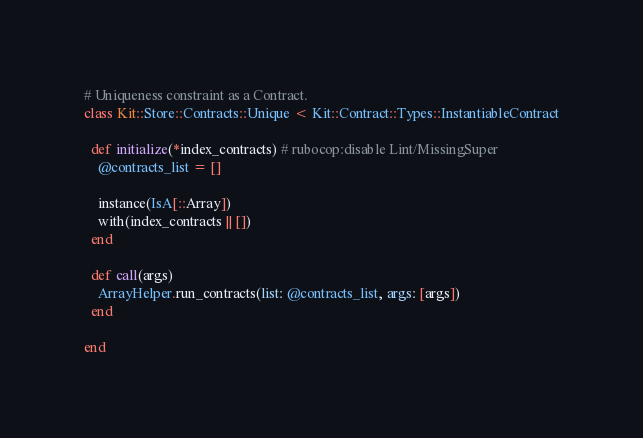<code> <loc_0><loc_0><loc_500><loc_500><_Ruby_># Uniqueness constraint as a Contract.
class Kit::Store::Contracts::Unique < Kit::Contract::Types::InstantiableContract

  def initialize(*index_contracts) # rubocop:disable Lint/MissingSuper
    @contracts_list = []

    instance(IsA[::Array])
    with(index_contracts || [])
  end

  def call(args)
    ArrayHelper.run_contracts(list: @contracts_list, args: [args])
  end

end
</code> 